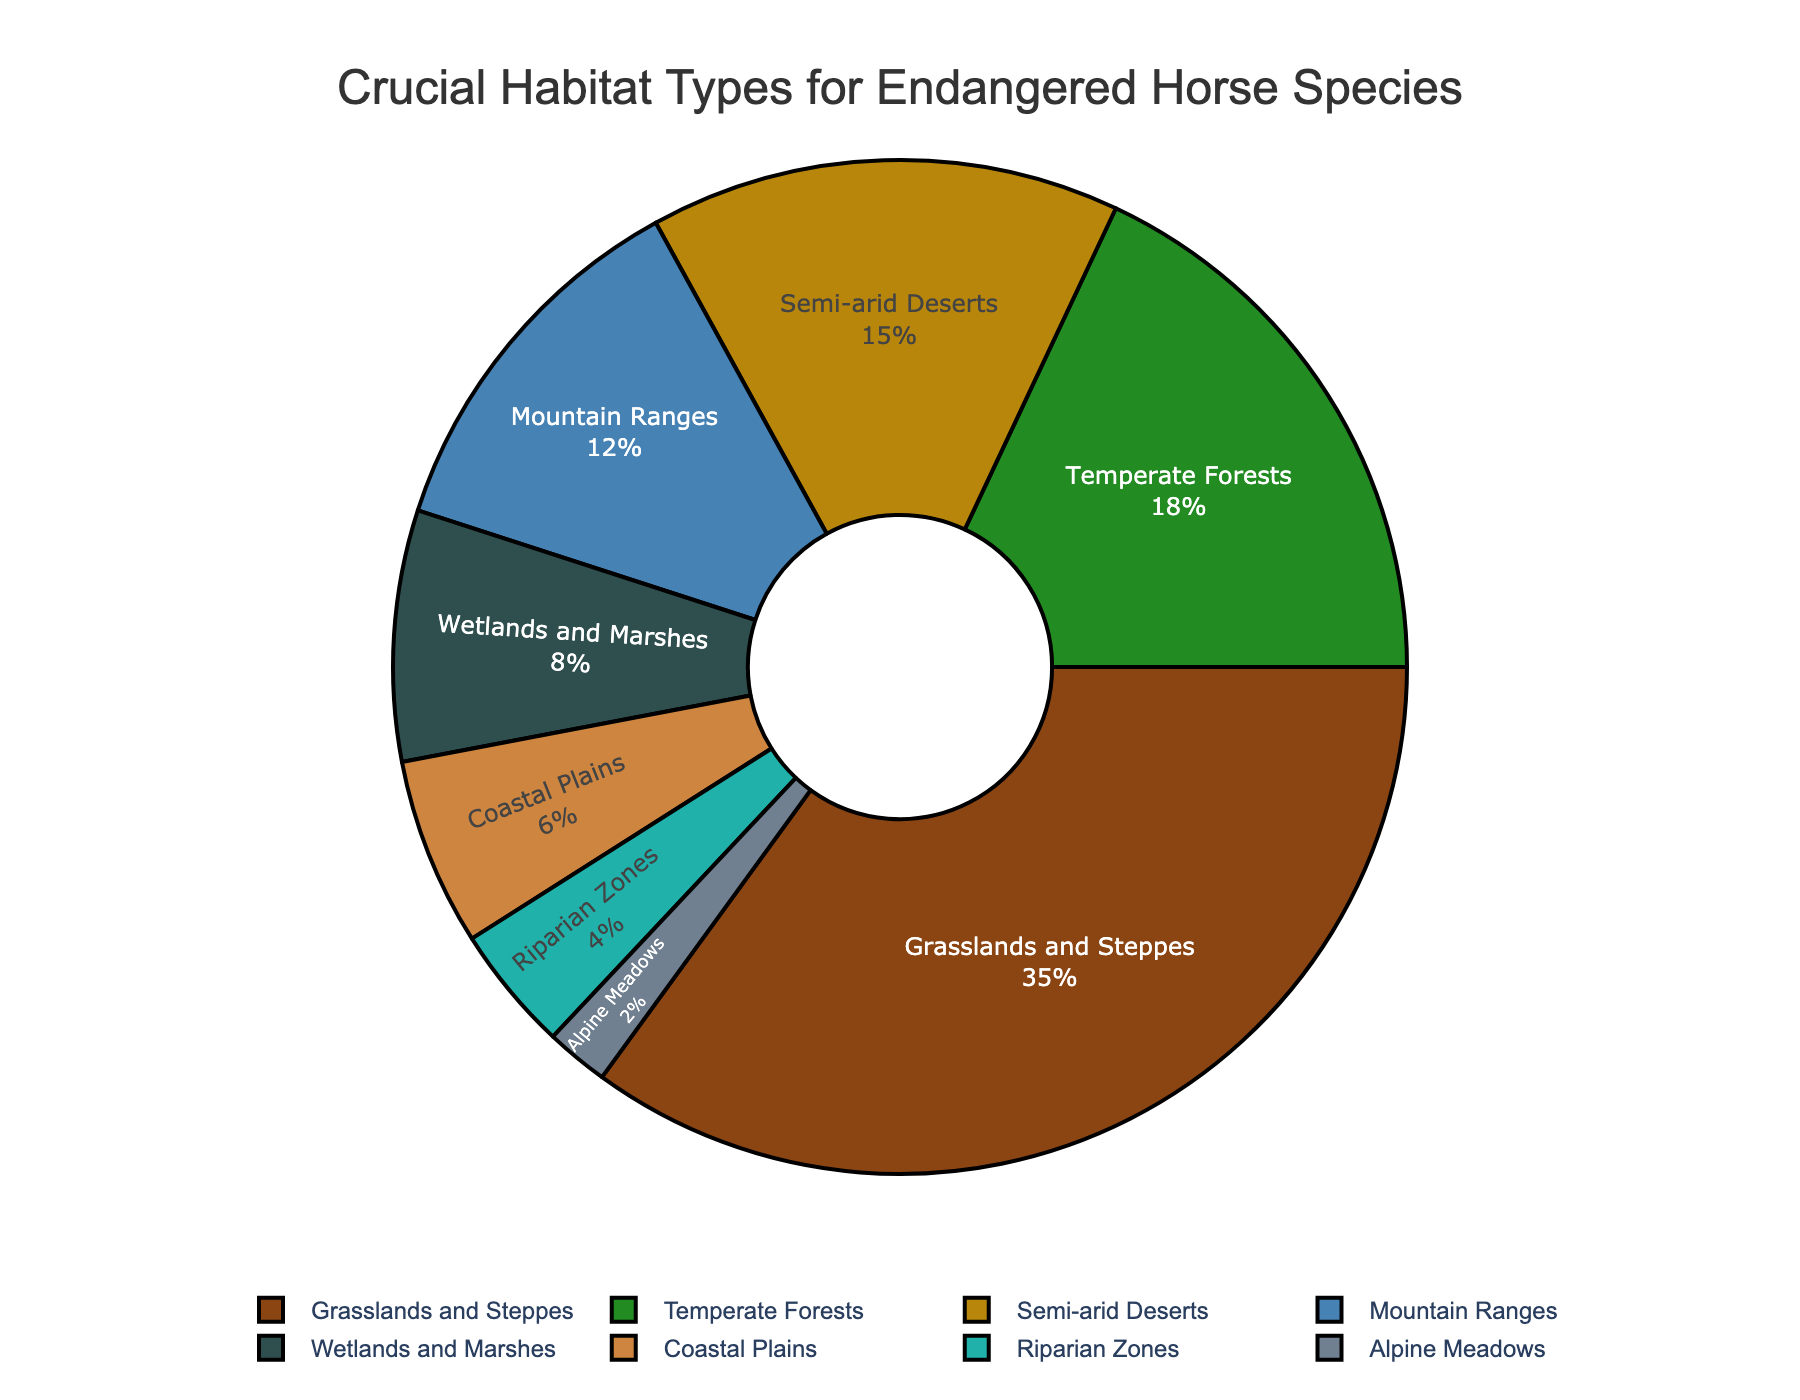What's the largest habitat type for endangered horse species survival? The largest habitat type can be identified by looking at the pie section with the largest area. Grasslands and Steppes have the largest area in the pie chart, indicating it is the largest habitat type.
Answer: Grasslands and Steppes Which habitat type has the smallest proportion? To find the smallest proportion, look for the pie section that is the smallest in size. Alpine Meadows is the smallest slice in the pie chart, indicating it's the habitat type with the smallest proportion.
Answer: Alpine Meadows How much greater is the percentage of Grasslands and Steppes compared to Riparian Zones? Grasslands and Steppes is 35%, and Riparian Zones is 4%. The difference is calculated as 35% - 4% = 31%.
Answer: 31% Which two habitat types have a combined percentage of 20%? By adding the percentages of each type: Coastal Plains (6%) and Riparian Zones (4%) make 10%; Alpine Meadows (2%) and Riparian Zones (4%) make 6%, which led to Temperate Forests (18%) being the most logical to combine with a smaller portion. Temperate Forests (18%) plus Alpine Meadows (2%) make exactly 20%.
Answer: Temperate Forests and Alpine Meadows Is the proportion of habitat types in Wetlands and Marshes greater than in Coastal Plains? Wetlands and Marshes have a percentage of 8%, and Coastal Plains have 6%. Since 8% is greater than 6%, the answer is yes.
Answer: Yes Which habitat type has double the percentage of Mountain Ranges? Mountain Ranges have a percentage of 12%. The habitat type with double this percentage is Grasslands and Steppes, which is 35%. However, exact doubling is not possible, reaffirming Grasslands and Steppes is significant yet not exactly double. Confirmed by focusing on math verification.
Answer: Grasslands and Steppes How many habitat types make up at least half of the pie chart combined? To determine how many habitats make up at least 50%, sum the percentages starting from the largest until reaching or surpassing 50%. Grasslands and Steppes (35%) + Temperate Forests (18%) = 53%. This sums up to 2 habitat types at least.
Answer: 2 What percentage more are the Temperate Forests than the Semi-arid Deserts? Temperate Forests are 18%, and Semi-arid Deserts are 15%. The difference is calculated as 18% - 15% = 3%.
Answer: 3% What is the combined percentage of Mountain Ranges and Wetlands and Marshes? Mountain Ranges have 12%, and Wetlands and Marshes have 8%. Adding these two percentages together: 12% + 8% = 20%.
Answer: 20% Which habitat type is closest in percentage to Wetlands and Marshes? Wetlands and Marshes are 8%, and by referring to the pie chart, Coastal Plains is the closest with 6%.
Answer: Coastal Plains 